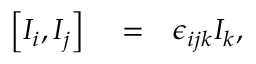<formula> <loc_0><loc_0><loc_500><loc_500>\begin{array} { r l r } { \left [ I _ { i } , I _ { j } \right ] } & = } & { \epsilon _ { i j k } I _ { k } , } \end{array}</formula> 